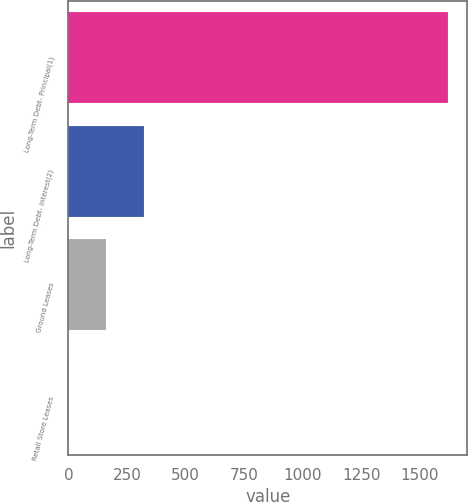<chart> <loc_0><loc_0><loc_500><loc_500><bar_chart><fcel>Long-Term Debt- Principal(1)<fcel>Long-Term Debt- Interest(2)<fcel>Ground Leases<fcel>Retail Store Leases<nl><fcel>1619.6<fcel>324.32<fcel>162.41<fcel>0.5<nl></chart> 